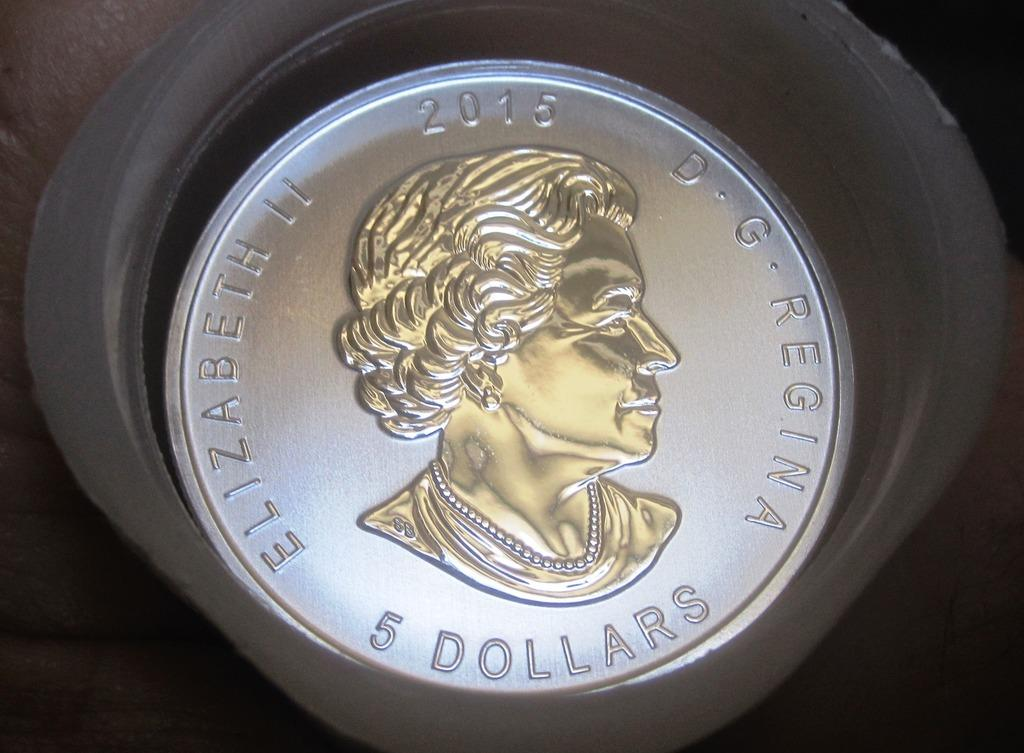What object is visible in the image? There is a coin in the image. Where might the coin be located? The coin may be on the floor. Can you describe the lighting conditions in the image? The image was likely taken during the night. What type of meal is being prepared in the image? There is no meal preparation visible in the image; it only features a coin. 